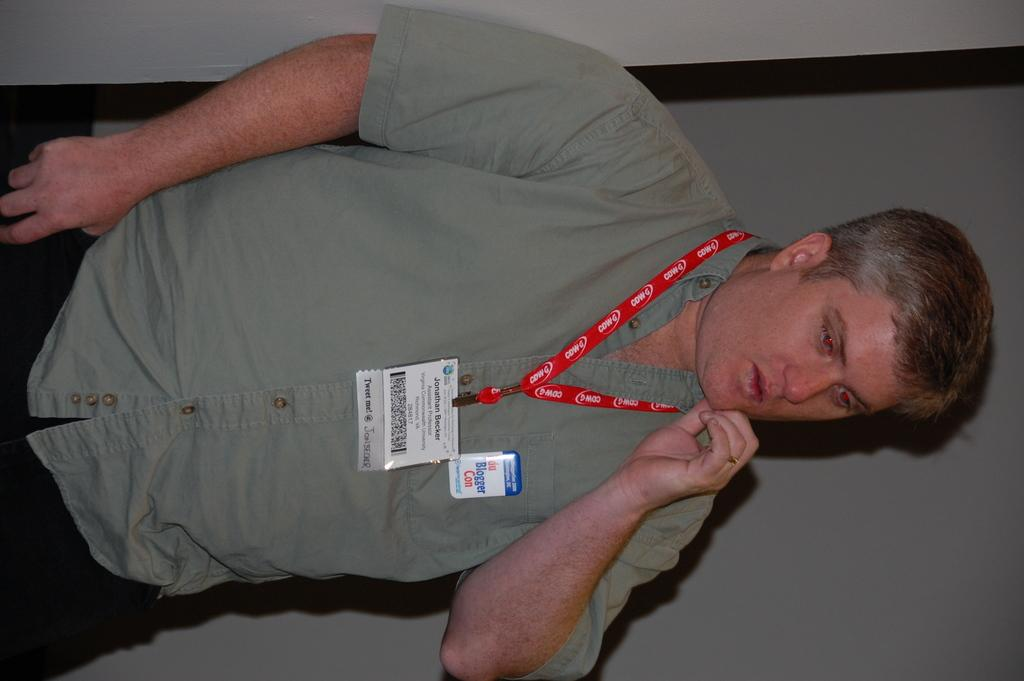What is the main subject of the image? There is a man standing in the image. Can you describe the background of the image? There is a wall in the background of the image. What book is the man reading in the image? There is no book present in the image; the man is simply standing. What type of land can be seen in the image? The image does not show any land; it only features a man standing in front of a wall. 